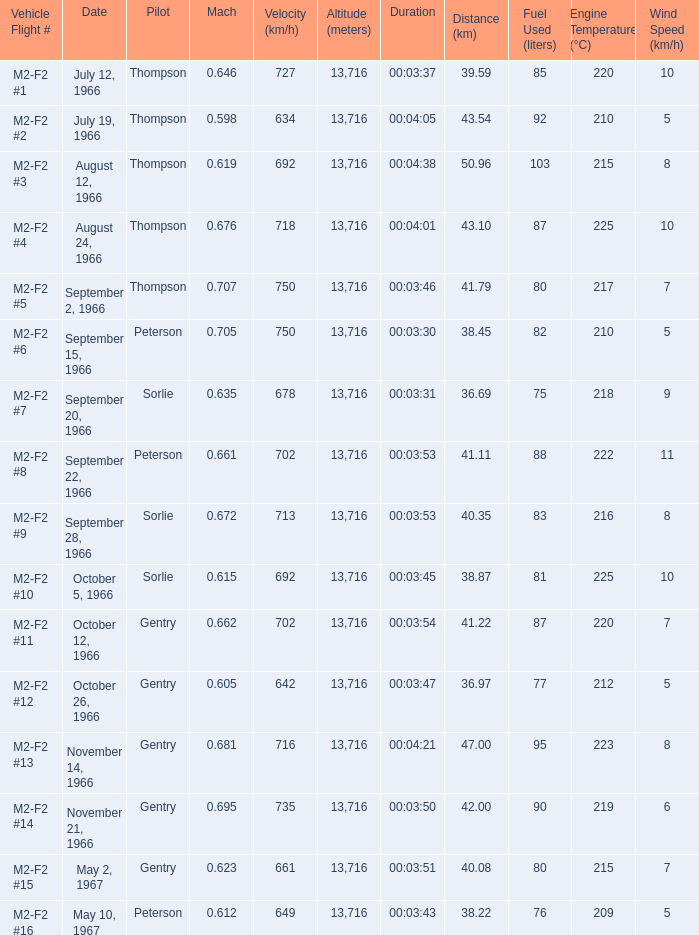What is the Mach with Vehicle Flight # m2-f2 #8 and an Altitude (meters) greater than 13,716? None. 